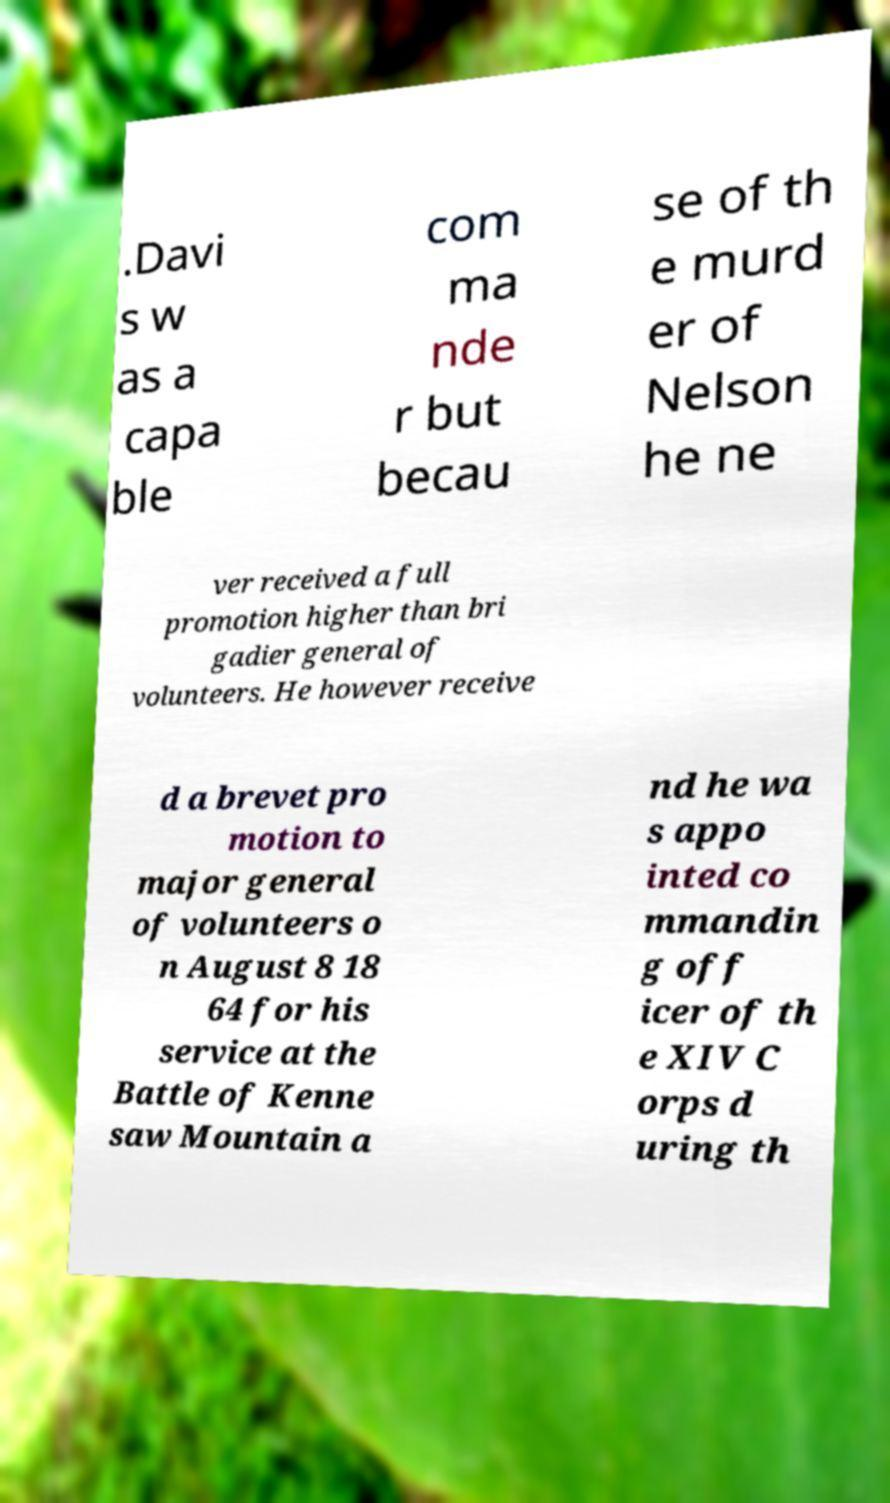What messages or text are displayed in this image? I need them in a readable, typed format. .Davi s w as a capa ble com ma nde r but becau se of th e murd er of Nelson he ne ver received a full promotion higher than bri gadier general of volunteers. He however receive d a brevet pro motion to major general of volunteers o n August 8 18 64 for his service at the Battle of Kenne saw Mountain a nd he wa s appo inted co mmandin g off icer of th e XIV C orps d uring th 